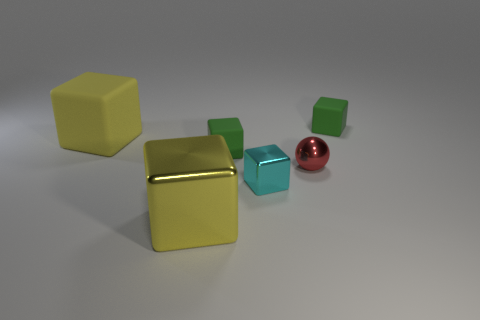Is the color of the big metal block the same as the large matte block?
Your answer should be compact. Yes. Is the material of the red ball the same as the small cyan object?
Offer a very short reply. Yes. What number of yellow things are on the left side of the yellow object to the right of the large yellow rubber cube?
Give a very brief answer. 1. Are there any large yellow matte objects of the same shape as the big shiny thing?
Keep it short and to the point. Yes. There is a big yellow thing left of the yellow metal object; is its shape the same as the small green rubber thing on the right side of the ball?
Ensure brevity in your answer.  Yes. There is a thing that is in front of the large yellow matte object and to the right of the cyan shiny object; what is its shape?
Provide a short and direct response. Sphere. Are there any other yellow cubes that have the same size as the yellow shiny block?
Keep it short and to the point. Yes. There is a tiny metallic cube; is its color the same as the small block that is behind the large matte block?
Provide a succinct answer. No. What is the material of the small ball?
Provide a short and direct response. Metal. There is a tiny rubber block that is on the left side of the tiny cyan metal block; what is its color?
Keep it short and to the point. Green. 